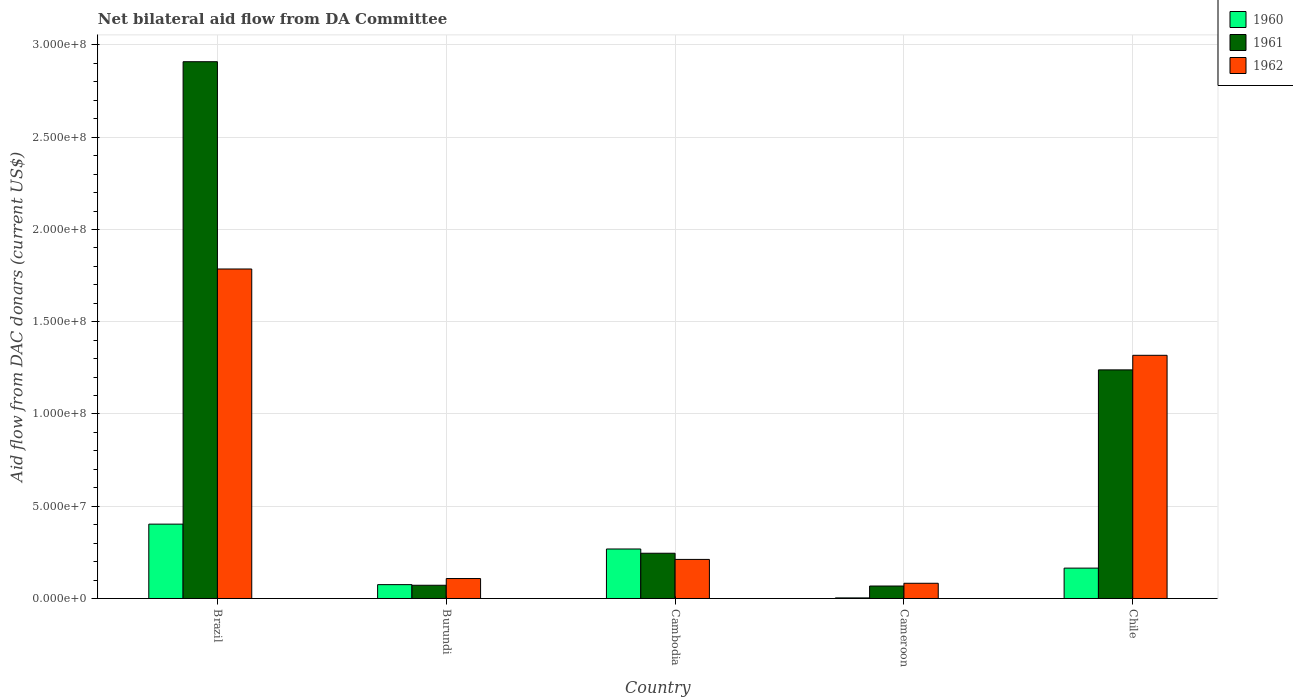How many groups of bars are there?
Offer a terse response. 5. Are the number of bars per tick equal to the number of legend labels?
Your answer should be compact. Yes. Are the number of bars on each tick of the X-axis equal?
Your answer should be compact. Yes. How many bars are there on the 4th tick from the right?
Offer a terse response. 3. What is the label of the 4th group of bars from the left?
Keep it short and to the point. Cameroon. What is the aid flow in in 1962 in Brazil?
Provide a succinct answer. 1.79e+08. Across all countries, what is the maximum aid flow in in 1960?
Keep it short and to the point. 4.03e+07. Across all countries, what is the minimum aid flow in in 1962?
Your answer should be compact. 8.25e+06. In which country was the aid flow in in 1960 maximum?
Make the answer very short. Brazil. In which country was the aid flow in in 1962 minimum?
Provide a succinct answer. Cameroon. What is the total aid flow in in 1961 in the graph?
Your response must be concise. 4.53e+08. What is the difference between the aid flow in in 1960 in Burundi and that in Cameroon?
Keep it short and to the point. 7.19e+06. What is the difference between the aid flow in in 1962 in Cambodia and the aid flow in in 1960 in Cameroon?
Ensure brevity in your answer.  2.09e+07. What is the average aid flow in in 1961 per country?
Offer a terse response. 9.07e+07. What is the difference between the aid flow in of/in 1960 and aid flow in of/in 1961 in Burundi?
Provide a short and direct response. 3.40e+05. In how many countries, is the aid flow in in 1961 greater than 140000000 US$?
Provide a short and direct response. 1. What is the ratio of the aid flow in in 1960 in Cambodia to that in Cameroon?
Offer a very short reply. 83.84. What is the difference between the highest and the second highest aid flow in in 1960?
Ensure brevity in your answer.  2.38e+07. What is the difference between the highest and the lowest aid flow in in 1960?
Provide a short and direct response. 4.00e+07. Is the sum of the aid flow in in 1960 in Cameroon and Chile greater than the maximum aid flow in in 1961 across all countries?
Your answer should be compact. No. Is it the case that in every country, the sum of the aid flow in in 1962 and aid flow in in 1961 is greater than the aid flow in in 1960?
Your answer should be compact. Yes. How many bars are there?
Provide a succinct answer. 15. Are all the bars in the graph horizontal?
Make the answer very short. No. Are the values on the major ticks of Y-axis written in scientific E-notation?
Offer a very short reply. Yes. Where does the legend appear in the graph?
Provide a short and direct response. Top right. What is the title of the graph?
Your answer should be very brief. Net bilateral aid flow from DA Committee. Does "1978" appear as one of the legend labels in the graph?
Offer a very short reply. No. What is the label or title of the Y-axis?
Your answer should be very brief. Aid flow from DAC donars (current US$). What is the Aid flow from DAC donars (current US$) in 1960 in Brazil?
Provide a succinct answer. 4.03e+07. What is the Aid flow from DAC donars (current US$) in 1961 in Brazil?
Keep it short and to the point. 2.91e+08. What is the Aid flow from DAC donars (current US$) of 1962 in Brazil?
Give a very brief answer. 1.79e+08. What is the Aid flow from DAC donars (current US$) of 1960 in Burundi?
Ensure brevity in your answer.  7.51e+06. What is the Aid flow from DAC donars (current US$) in 1961 in Burundi?
Make the answer very short. 7.17e+06. What is the Aid flow from DAC donars (current US$) in 1962 in Burundi?
Give a very brief answer. 1.08e+07. What is the Aid flow from DAC donars (current US$) of 1960 in Cambodia?
Make the answer very short. 2.68e+07. What is the Aid flow from DAC donars (current US$) in 1961 in Cambodia?
Keep it short and to the point. 2.45e+07. What is the Aid flow from DAC donars (current US$) in 1962 in Cambodia?
Offer a very short reply. 2.12e+07. What is the Aid flow from DAC donars (current US$) of 1961 in Cameroon?
Your response must be concise. 6.76e+06. What is the Aid flow from DAC donars (current US$) in 1962 in Cameroon?
Offer a terse response. 8.25e+06. What is the Aid flow from DAC donars (current US$) in 1960 in Chile?
Keep it short and to the point. 1.65e+07. What is the Aid flow from DAC donars (current US$) in 1961 in Chile?
Offer a terse response. 1.24e+08. What is the Aid flow from DAC donars (current US$) in 1962 in Chile?
Provide a short and direct response. 1.32e+08. Across all countries, what is the maximum Aid flow from DAC donars (current US$) in 1960?
Offer a terse response. 4.03e+07. Across all countries, what is the maximum Aid flow from DAC donars (current US$) in 1961?
Give a very brief answer. 2.91e+08. Across all countries, what is the maximum Aid flow from DAC donars (current US$) in 1962?
Make the answer very short. 1.79e+08. Across all countries, what is the minimum Aid flow from DAC donars (current US$) of 1961?
Your response must be concise. 6.76e+06. Across all countries, what is the minimum Aid flow from DAC donars (current US$) in 1962?
Offer a terse response. 8.25e+06. What is the total Aid flow from DAC donars (current US$) in 1960 in the graph?
Offer a terse response. 9.14e+07. What is the total Aid flow from DAC donars (current US$) in 1961 in the graph?
Your answer should be very brief. 4.53e+08. What is the total Aid flow from DAC donars (current US$) of 1962 in the graph?
Your response must be concise. 3.51e+08. What is the difference between the Aid flow from DAC donars (current US$) of 1960 in Brazil and that in Burundi?
Ensure brevity in your answer.  3.28e+07. What is the difference between the Aid flow from DAC donars (current US$) of 1961 in Brazil and that in Burundi?
Keep it short and to the point. 2.84e+08. What is the difference between the Aid flow from DAC donars (current US$) in 1962 in Brazil and that in Burundi?
Offer a very short reply. 1.68e+08. What is the difference between the Aid flow from DAC donars (current US$) in 1960 in Brazil and that in Cambodia?
Ensure brevity in your answer.  1.35e+07. What is the difference between the Aid flow from DAC donars (current US$) of 1961 in Brazil and that in Cambodia?
Your response must be concise. 2.66e+08. What is the difference between the Aid flow from DAC donars (current US$) of 1962 in Brazil and that in Cambodia?
Offer a very short reply. 1.57e+08. What is the difference between the Aid flow from DAC donars (current US$) of 1960 in Brazil and that in Cameroon?
Give a very brief answer. 4.00e+07. What is the difference between the Aid flow from DAC donars (current US$) of 1961 in Brazil and that in Cameroon?
Provide a succinct answer. 2.84e+08. What is the difference between the Aid flow from DAC donars (current US$) of 1962 in Brazil and that in Cameroon?
Provide a succinct answer. 1.70e+08. What is the difference between the Aid flow from DAC donars (current US$) of 1960 in Brazil and that in Chile?
Ensure brevity in your answer.  2.38e+07. What is the difference between the Aid flow from DAC donars (current US$) of 1961 in Brazil and that in Chile?
Your response must be concise. 1.67e+08. What is the difference between the Aid flow from DAC donars (current US$) of 1962 in Brazil and that in Chile?
Make the answer very short. 4.68e+07. What is the difference between the Aid flow from DAC donars (current US$) in 1960 in Burundi and that in Cambodia?
Offer a very short reply. -1.93e+07. What is the difference between the Aid flow from DAC donars (current US$) in 1961 in Burundi and that in Cambodia?
Offer a terse response. -1.74e+07. What is the difference between the Aid flow from DAC donars (current US$) of 1962 in Burundi and that in Cambodia?
Offer a very short reply. -1.04e+07. What is the difference between the Aid flow from DAC donars (current US$) in 1960 in Burundi and that in Cameroon?
Provide a short and direct response. 7.19e+06. What is the difference between the Aid flow from DAC donars (current US$) of 1962 in Burundi and that in Cameroon?
Your response must be concise. 2.56e+06. What is the difference between the Aid flow from DAC donars (current US$) in 1960 in Burundi and that in Chile?
Give a very brief answer. -8.95e+06. What is the difference between the Aid flow from DAC donars (current US$) of 1961 in Burundi and that in Chile?
Your response must be concise. -1.17e+08. What is the difference between the Aid flow from DAC donars (current US$) in 1962 in Burundi and that in Chile?
Offer a very short reply. -1.21e+08. What is the difference between the Aid flow from DAC donars (current US$) of 1960 in Cambodia and that in Cameroon?
Ensure brevity in your answer.  2.65e+07. What is the difference between the Aid flow from DAC donars (current US$) of 1961 in Cambodia and that in Cameroon?
Keep it short and to the point. 1.78e+07. What is the difference between the Aid flow from DAC donars (current US$) of 1962 in Cambodia and that in Cameroon?
Provide a short and direct response. 1.29e+07. What is the difference between the Aid flow from DAC donars (current US$) of 1960 in Cambodia and that in Chile?
Keep it short and to the point. 1.04e+07. What is the difference between the Aid flow from DAC donars (current US$) of 1961 in Cambodia and that in Chile?
Your answer should be very brief. -9.94e+07. What is the difference between the Aid flow from DAC donars (current US$) of 1962 in Cambodia and that in Chile?
Your answer should be very brief. -1.11e+08. What is the difference between the Aid flow from DAC donars (current US$) in 1960 in Cameroon and that in Chile?
Provide a succinct answer. -1.61e+07. What is the difference between the Aid flow from DAC donars (current US$) of 1961 in Cameroon and that in Chile?
Ensure brevity in your answer.  -1.17e+08. What is the difference between the Aid flow from DAC donars (current US$) of 1962 in Cameroon and that in Chile?
Give a very brief answer. -1.24e+08. What is the difference between the Aid flow from DAC donars (current US$) of 1960 in Brazil and the Aid flow from DAC donars (current US$) of 1961 in Burundi?
Your response must be concise. 3.31e+07. What is the difference between the Aid flow from DAC donars (current US$) in 1960 in Brazil and the Aid flow from DAC donars (current US$) in 1962 in Burundi?
Your answer should be compact. 2.95e+07. What is the difference between the Aid flow from DAC donars (current US$) in 1961 in Brazil and the Aid flow from DAC donars (current US$) in 1962 in Burundi?
Provide a succinct answer. 2.80e+08. What is the difference between the Aid flow from DAC donars (current US$) in 1960 in Brazil and the Aid flow from DAC donars (current US$) in 1961 in Cambodia?
Your answer should be compact. 1.58e+07. What is the difference between the Aid flow from DAC donars (current US$) in 1960 in Brazil and the Aid flow from DAC donars (current US$) in 1962 in Cambodia?
Your response must be concise. 1.91e+07. What is the difference between the Aid flow from DAC donars (current US$) in 1961 in Brazil and the Aid flow from DAC donars (current US$) in 1962 in Cambodia?
Ensure brevity in your answer.  2.70e+08. What is the difference between the Aid flow from DAC donars (current US$) of 1960 in Brazil and the Aid flow from DAC donars (current US$) of 1961 in Cameroon?
Make the answer very short. 3.35e+07. What is the difference between the Aid flow from DAC donars (current US$) in 1960 in Brazil and the Aid flow from DAC donars (current US$) in 1962 in Cameroon?
Your response must be concise. 3.20e+07. What is the difference between the Aid flow from DAC donars (current US$) in 1961 in Brazil and the Aid flow from DAC donars (current US$) in 1962 in Cameroon?
Provide a succinct answer. 2.83e+08. What is the difference between the Aid flow from DAC donars (current US$) of 1960 in Brazil and the Aid flow from DAC donars (current US$) of 1961 in Chile?
Your answer should be very brief. -8.36e+07. What is the difference between the Aid flow from DAC donars (current US$) of 1960 in Brazil and the Aid flow from DAC donars (current US$) of 1962 in Chile?
Offer a terse response. -9.15e+07. What is the difference between the Aid flow from DAC donars (current US$) of 1961 in Brazil and the Aid flow from DAC donars (current US$) of 1962 in Chile?
Offer a very short reply. 1.59e+08. What is the difference between the Aid flow from DAC donars (current US$) in 1960 in Burundi and the Aid flow from DAC donars (current US$) in 1961 in Cambodia?
Give a very brief answer. -1.70e+07. What is the difference between the Aid flow from DAC donars (current US$) of 1960 in Burundi and the Aid flow from DAC donars (current US$) of 1962 in Cambodia?
Provide a succinct answer. -1.37e+07. What is the difference between the Aid flow from DAC donars (current US$) in 1961 in Burundi and the Aid flow from DAC donars (current US$) in 1962 in Cambodia?
Your response must be concise. -1.40e+07. What is the difference between the Aid flow from DAC donars (current US$) of 1960 in Burundi and the Aid flow from DAC donars (current US$) of 1961 in Cameroon?
Ensure brevity in your answer.  7.50e+05. What is the difference between the Aid flow from DAC donars (current US$) in 1960 in Burundi and the Aid flow from DAC donars (current US$) in 1962 in Cameroon?
Give a very brief answer. -7.40e+05. What is the difference between the Aid flow from DAC donars (current US$) in 1961 in Burundi and the Aid flow from DAC donars (current US$) in 1962 in Cameroon?
Your response must be concise. -1.08e+06. What is the difference between the Aid flow from DAC donars (current US$) of 1960 in Burundi and the Aid flow from DAC donars (current US$) of 1961 in Chile?
Make the answer very short. -1.16e+08. What is the difference between the Aid flow from DAC donars (current US$) in 1960 in Burundi and the Aid flow from DAC donars (current US$) in 1962 in Chile?
Your answer should be compact. -1.24e+08. What is the difference between the Aid flow from DAC donars (current US$) in 1961 in Burundi and the Aid flow from DAC donars (current US$) in 1962 in Chile?
Offer a very short reply. -1.25e+08. What is the difference between the Aid flow from DAC donars (current US$) in 1960 in Cambodia and the Aid flow from DAC donars (current US$) in 1961 in Cameroon?
Your response must be concise. 2.01e+07. What is the difference between the Aid flow from DAC donars (current US$) of 1960 in Cambodia and the Aid flow from DAC donars (current US$) of 1962 in Cameroon?
Make the answer very short. 1.86e+07. What is the difference between the Aid flow from DAC donars (current US$) in 1961 in Cambodia and the Aid flow from DAC donars (current US$) in 1962 in Cameroon?
Offer a very short reply. 1.63e+07. What is the difference between the Aid flow from DAC donars (current US$) in 1960 in Cambodia and the Aid flow from DAC donars (current US$) in 1961 in Chile?
Provide a short and direct response. -9.71e+07. What is the difference between the Aid flow from DAC donars (current US$) in 1960 in Cambodia and the Aid flow from DAC donars (current US$) in 1962 in Chile?
Your response must be concise. -1.05e+08. What is the difference between the Aid flow from DAC donars (current US$) in 1961 in Cambodia and the Aid flow from DAC donars (current US$) in 1962 in Chile?
Provide a succinct answer. -1.07e+08. What is the difference between the Aid flow from DAC donars (current US$) of 1960 in Cameroon and the Aid flow from DAC donars (current US$) of 1961 in Chile?
Make the answer very short. -1.24e+08. What is the difference between the Aid flow from DAC donars (current US$) of 1960 in Cameroon and the Aid flow from DAC donars (current US$) of 1962 in Chile?
Ensure brevity in your answer.  -1.31e+08. What is the difference between the Aid flow from DAC donars (current US$) of 1961 in Cameroon and the Aid flow from DAC donars (current US$) of 1962 in Chile?
Your response must be concise. -1.25e+08. What is the average Aid flow from DAC donars (current US$) in 1960 per country?
Provide a short and direct response. 1.83e+07. What is the average Aid flow from DAC donars (current US$) in 1961 per country?
Provide a short and direct response. 9.07e+07. What is the average Aid flow from DAC donars (current US$) in 1962 per country?
Your answer should be compact. 7.01e+07. What is the difference between the Aid flow from DAC donars (current US$) of 1960 and Aid flow from DAC donars (current US$) of 1961 in Brazil?
Provide a succinct answer. -2.51e+08. What is the difference between the Aid flow from DAC donars (current US$) of 1960 and Aid flow from DAC donars (current US$) of 1962 in Brazil?
Your answer should be very brief. -1.38e+08. What is the difference between the Aid flow from DAC donars (current US$) in 1961 and Aid flow from DAC donars (current US$) in 1962 in Brazil?
Offer a terse response. 1.12e+08. What is the difference between the Aid flow from DAC donars (current US$) of 1960 and Aid flow from DAC donars (current US$) of 1961 in Burundi?
Offer a terse response. 3.40e+05. What is the difference between the Aid flow from DAC donars (current US$) of 1960 and Aid flow from DAC donars (current US$) of 1962 in Burundi?
Provide a short and direct response. -3.30e+06. What is the difference between the Aid flow from DAC donars (current US$) in 1961 and Aid flow from DAC donars (current US$) in 1962 in Burundi?
Your answer should be very brief. -3.64e+06. What is the difference between the Aid flow from DAC donars (current US$) in 1960 and Aid flow from DAC donars (current US$) in 1961 in Cambodia?
Ensure brevity in your answer.  2.31e+06. What is the difference between the Aid flow from DAC donars (current US$) in 1960 and Aid flow from DAC donars (current US$) in 1962 in Cambodia?
Provide a short and direct response. 5.65e+06. What is the difference between the Aid flow from DAC donars (current US$) in 1961 and Aid flow from DAC donars (current US$) in 1962 in Cambodia?
Your answer should be very brief. 3.34e+06. What is the difference between the Aid flow from DAC donars (current US$) of 1960 and Aid flow from DAC donars (current US$) of 1961 in Cameroon?
Make the answer very short. -6.44e+06. What is the difference between the Aid flow from DAC donars (current US$) in 1960 and Aid flow from DAC donars (current US$) in 1962 in Cameroon?
Provide a short and direct response. -7.93e+06. What is the difference between the Aid flow from DAC donars (current US$) of 1961 and Aid flow from DAC donars (current US$) of 1962 in Cameroon?
Ensure brevity in your answer.  -1.49e+06. What is the difference between the Aid flow from DAC donars (current US$) of 1960 and Aid flow from DAC donars (current US$) of 1961 in Chile?
Your answer should be very brief. -1.07e+08. What is the difference between the Aid flow from DAC donars (current US$) of 1960 and Aid flow from DAC donars (current US$) of 1962 in Chile?
Your response must be concise. -1.15e+08. What is the difference between the Aid flow from DAC donars (current US$) in 1961 and Aid flow from DAC donars (current US$) in 1962 in Chile?
Ensure brevity in your answer.  -7.90e+06. What is the ratio of the Aid flow from DAC donars (current US$) in 1960 in Brazil to that in Burundi?
Your answer should be very brief. 5.37. What is the ratio of the Aid flow from DAC donars (current US$) in 1961 in Brazil to that in Burundi?
Your response must be concise. 40.57. What is the ratio of the Aid flow from DAC donars (current US$) of 1962 in Brazil to that in Burundi?
Offer a very short reply. 16.52. What is the ratio of the Aid flow from DAC donars (current US$) in 1960 in Brazil to that in Cambodia?
Offer a very short reply. 1.5. What is the ratio of the Aid flow from DAC donars (current US$) in 1961 in Brazil to that in Cambodia?
Give a very brief answer. 11.86. What is the ratio of the Aid flow from DAC donars (current US$) of 1962 in Brazil to that in Cambodia?
Your answer should be very brief. 8.43. What is the ratio of the Aid flow from DAC donars (current US$) of 1960 in Brazil to that in Cameroon?
Ensure brevity in your answer.  125.94. What is the ratio of the Aid flow from DAC donars (current US$) in 1961 in Brazil to that in Cameroon?
Keep it short and to the point. 43.04. What is the ratio of the Aid flow from DAC donars (current US$) in 1962 in Brazil to that in Cameroon?
Provide a succinct answer. 21.65. What is the ratio of the Aid flow from DAC donars (current US$) of 1960 in Brazil to that in Chile?
Provide a short and direct response. 2.45. What is the ratio of the Aid flow from DAC donars (current US$) of 1961 in Brazil to that in Chile?
Offer a terse response. 2.35. What is the ratio of the Aid flow from DAC donars (current US$) of 1962 in Brazil to that in Chile?
Provide a succinct answer. 1.35. What is the ratio of the Aid flow from DAC donars (current US$) in 1960 in Burundi to that in Cambodia?
Your answer should be compact. 0.28. What is the ratio of the Aid flow from DAC donars (current US$) in 1961 in Burundi to that in Cambodia?
Give a very brief answer. 0.29. What is the ratio of the Aid flow from DAC donars (current US$) in 1962 in Burundi to that in Cambodia?
Provide a short and direct response. 0.51. What is the ratio of the Aid flow from DAC donars (current US$) of 1960 in Burundi to that in Cameroon?
Keep it short and to the point. 23.47. What is the ratio of the Aid flow from DAC donars (current US$) of 1961 in Burundi to that in Cameroon?
Your answer should be compact. 1.06. What is the ratio of the Aid flow from DAC donars (current US$) of 1962 in Burundi to that in Cameroon?
Keep it short and to the point. 1.31. What is the ratio of the Aid flow from DAC donars (current US$) of 1960 in Burundi to that in Chile?
Provide a short and direct response. 0.46. What is the ratio of the Aid flow from DAC donars (current US$) in 1961 in Burundi to that in Chile?
Your answer should be compact. 0.06. What is the ratio of the Aid flow from DAC donars (current US$) of 1962 in Burundi to that in Chile?
Offer a terse response. 0.08. What is the ratio of the Aid flow from DAC donars (current US$) in 1960 in Cambodia to that in Cameroon?
Make the answer very short. 83.84. What is the ratio of the Aid flow from DAC donars (current US$) of 1961 in Cambodia to that in Cameroon?
Your answer should be very brief. 3.63. What is the ratio of the Aid flow from DAC donars (current US$) in 1962 in Cambodia to that in Cameroon?
Offer a very short reply. 2.57. What is the ratio of the Aid flow from DAC donars (current US$) of 1960 in Cambodia to that in Chile?
Offer a terse response. 1.63. What is the ratio of the Aid flow from DAC donars (current US$) in 1961 in Cambodia to that in Chile?
Provide a short and direct response. 0.2. What is the ratio of the Aid flow from DAC donars (current US$) of 1962 in Cambodia to that in Chile?
Make the answer very short. 0.16. What is the ratio of the Aid flow from DAC donars (current US$) of 1960 in Cameroon to that in Chile?
Offer a very short reply. 0.02. What is the ratio of the Aid flow from DAC donars (current US$) of 1961 in Cameroon to that in Chile?
Give a very brief answer. 0.05. What is the ratio of the Aid flow from DAC donars (current US$) of 1962 in Cameroon to that in Chile?
Your response must be concise. 0.06. What is the difference between the highest and the second highest Aid flow from DAC donars (current US$) of 1960?
Provide a short and direct response. 1.35e+07. What is the difference between the highest and the second highest Aid flow from DAC donars (current US$) in 1961?
Make the answer very short. 1.67e+08. What is the difference between the highest and the second highest Aid flow from DAC donars (current US$) of 1962?
Offer a very short reply. 4.68e+07. What is the difference between the highest and the lowest Aid flow from DAC donars (current US$) of 1960?
Provide a succinct answer. 4.00e+07. What is the difference between the highest and the lowest Aid flow from DAC donars (current US$) in 1961?
Offer a terse response. 2.84e+08. What is the difference between the highest and the lowest Aid flow from DAC donars (current US$) in 1962?
Provide a short and direct response. 1.70e+08. 